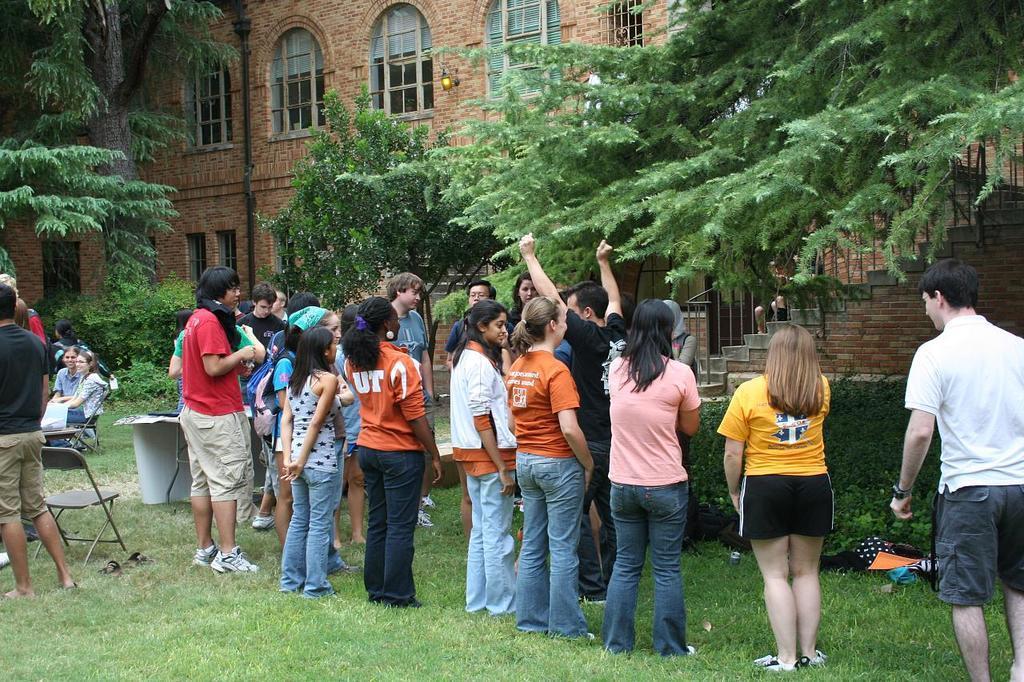Could you give a brief overview of what you see in this image? In this image people are standing on the surface of the grass and at the left side of the image there are chairs and two people are sitting on the chairs and at the back side there is a building. We can also see trees at the back side. 